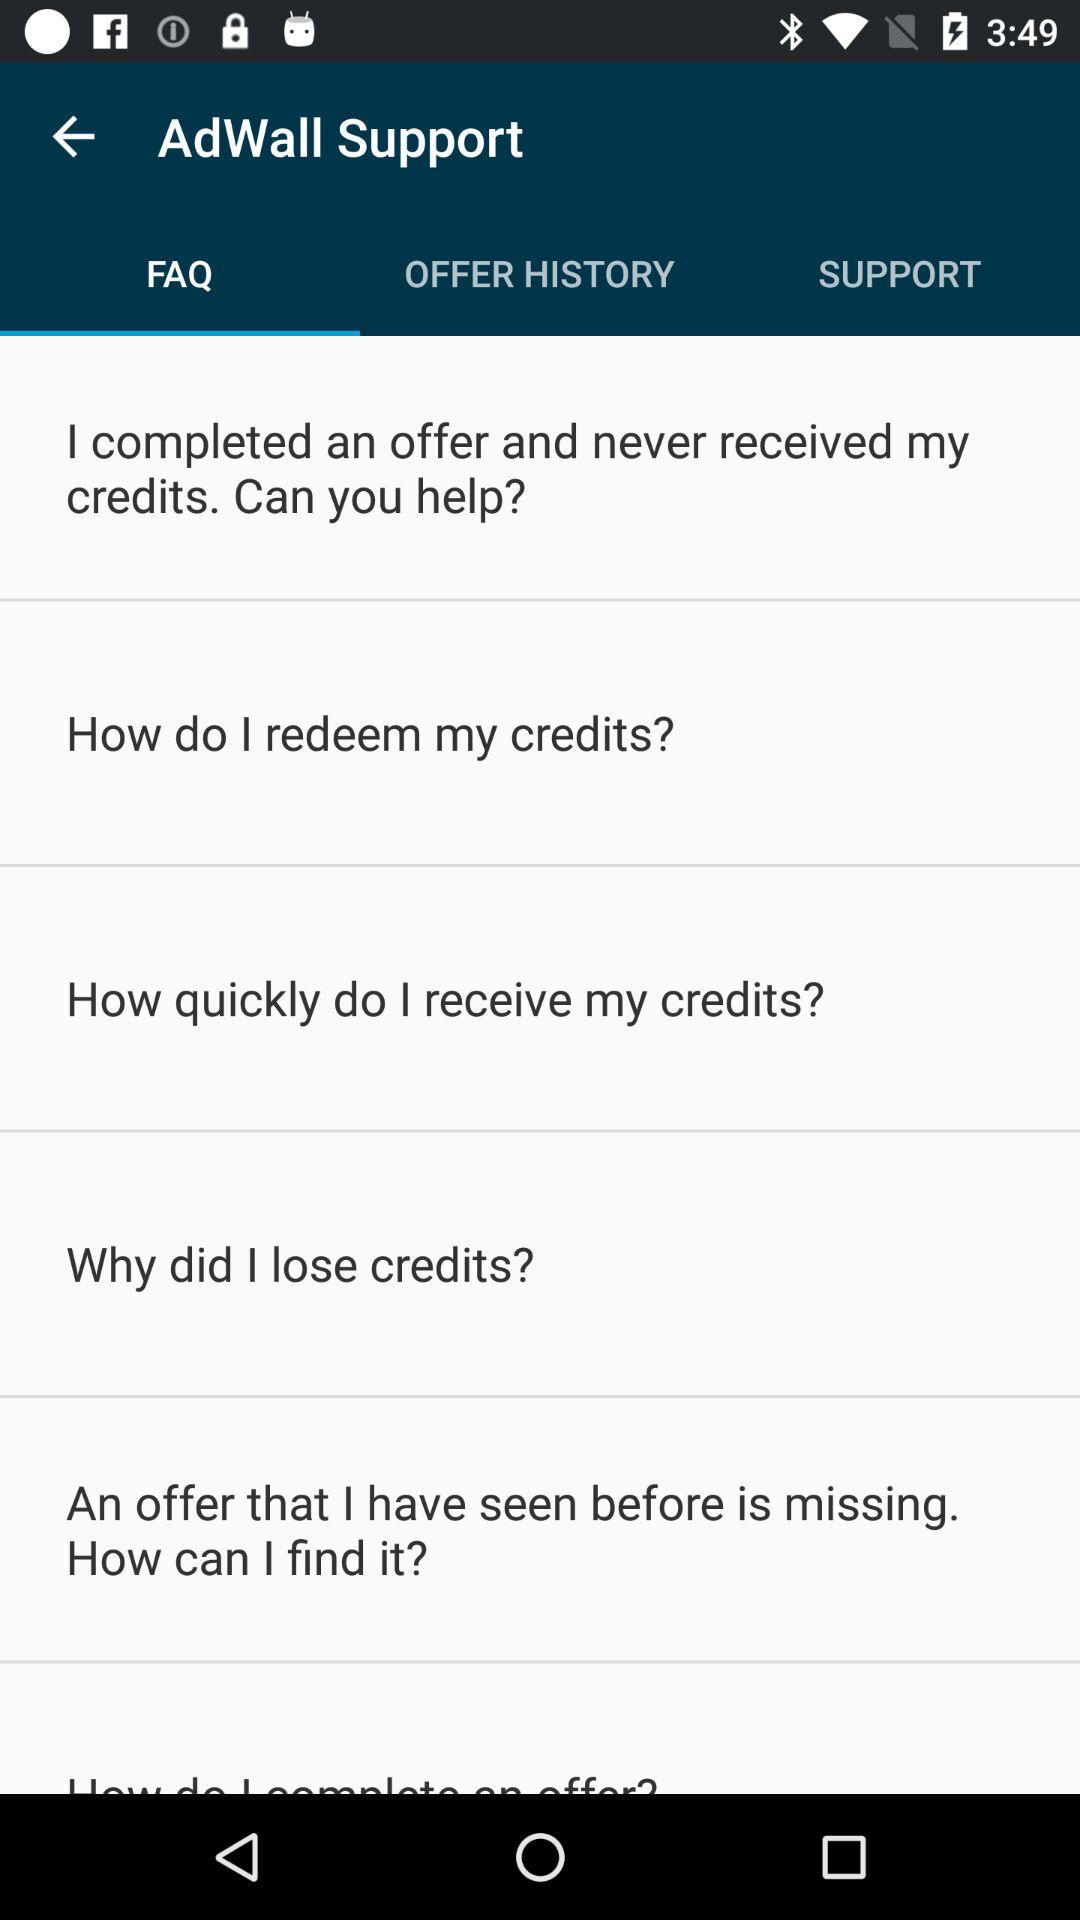Which option of "AdWall Support" is selected? The selected option is "FAQ". 